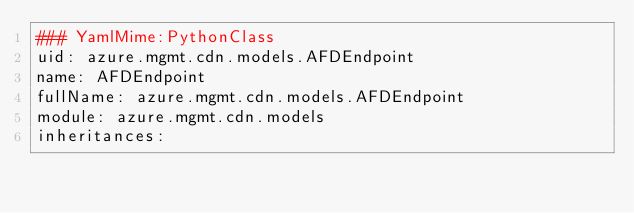<code> <loc_0><loc_0><loc_500><loc_500><_YAML_>### YamlMime:PythonClass
uid: azure.mgmt.cdn.models.AFDEndpoint
name: AFDEndpoint
fullName: azure.mgmt.cdn.models.AFDEndpoint
module: azure.mgmt.cdn.models
inheritances:</code> 